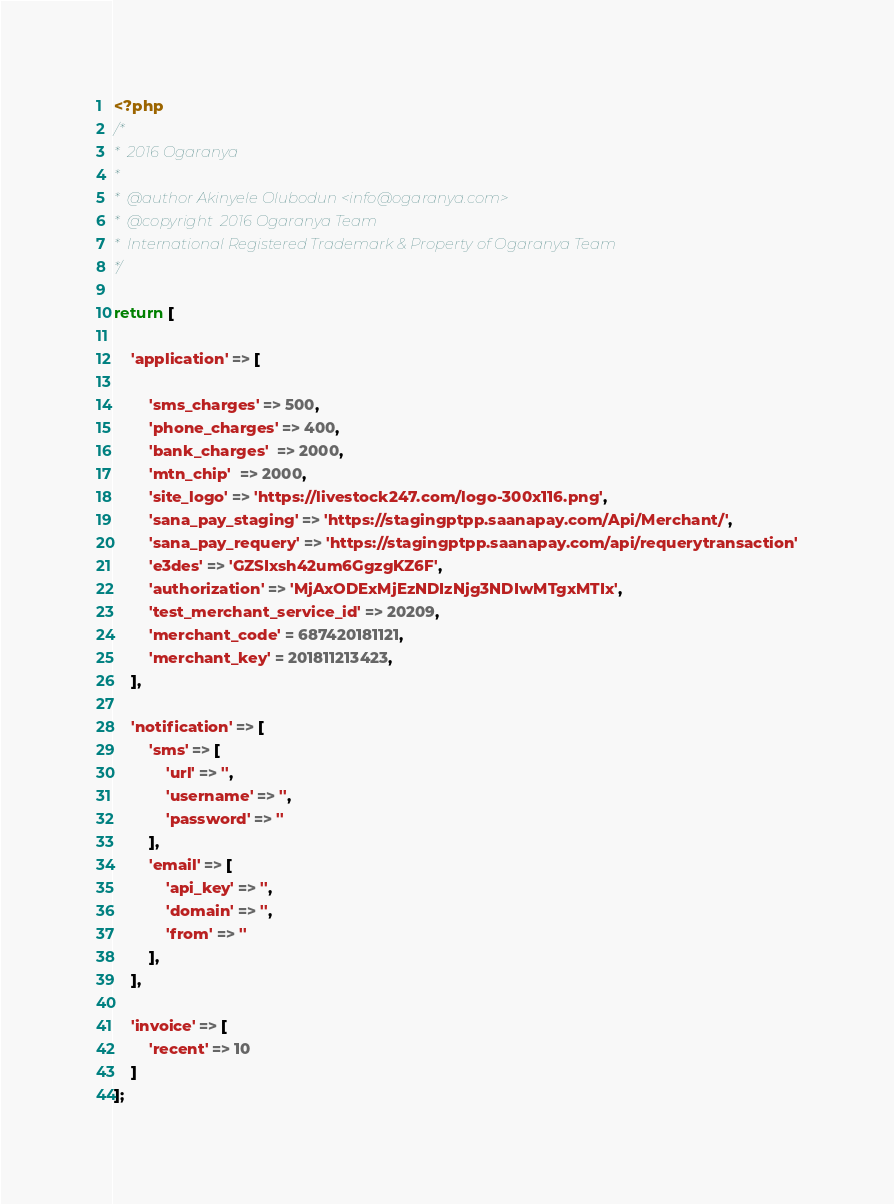<code> <loc_0><loc_0><loc_500><loc_500><_PHP_><?php
/*
*  2016 Ogaranya
*
*  @author Akinyele Olubodun <info@ogaranya.com>
*  @copyright  2016 Ogaranya Team
*  International Registered Trademark & Property of Ogaranya Team
*/

return [

    'application' => [

        'sms_charges' => 500,
        'phone_charges' => 400,
        'bank_charges'  => 2000,
        'mtn_chip'  => 2000,
        'site_logo' => 'https://livestock247.com/logo-300x116.png',
        'sana_pay_staging' => 'https://stagingptpp.saanapay.com/Api/Merchant/',
        'sana_pay_requery' => 'https://stagingptpp.saanapay.com/api/requerytransaction'
        'e3des' => 'GZSIxsh42um6GgzgKZ6F',
        'authorization' => 'MjAxODExMjEzNDIzNjg3NDIwMTgxMTIx',
        'test_merchant_service_id' => 20209,
        'merchant_code' = 687420181121,
        'merchant_key' = 201811213423,
    ],

    'notification' => [
        'sms' => [
            'url' => '',
            'username' => '',
            'password' => ''
        ],
        'email' => [
            'api_key' => '',
            'domain' => '',
            'from' => ''
        ],
    ],

    'invoice' => [
        'recent' => 10
    ]
];</code> 